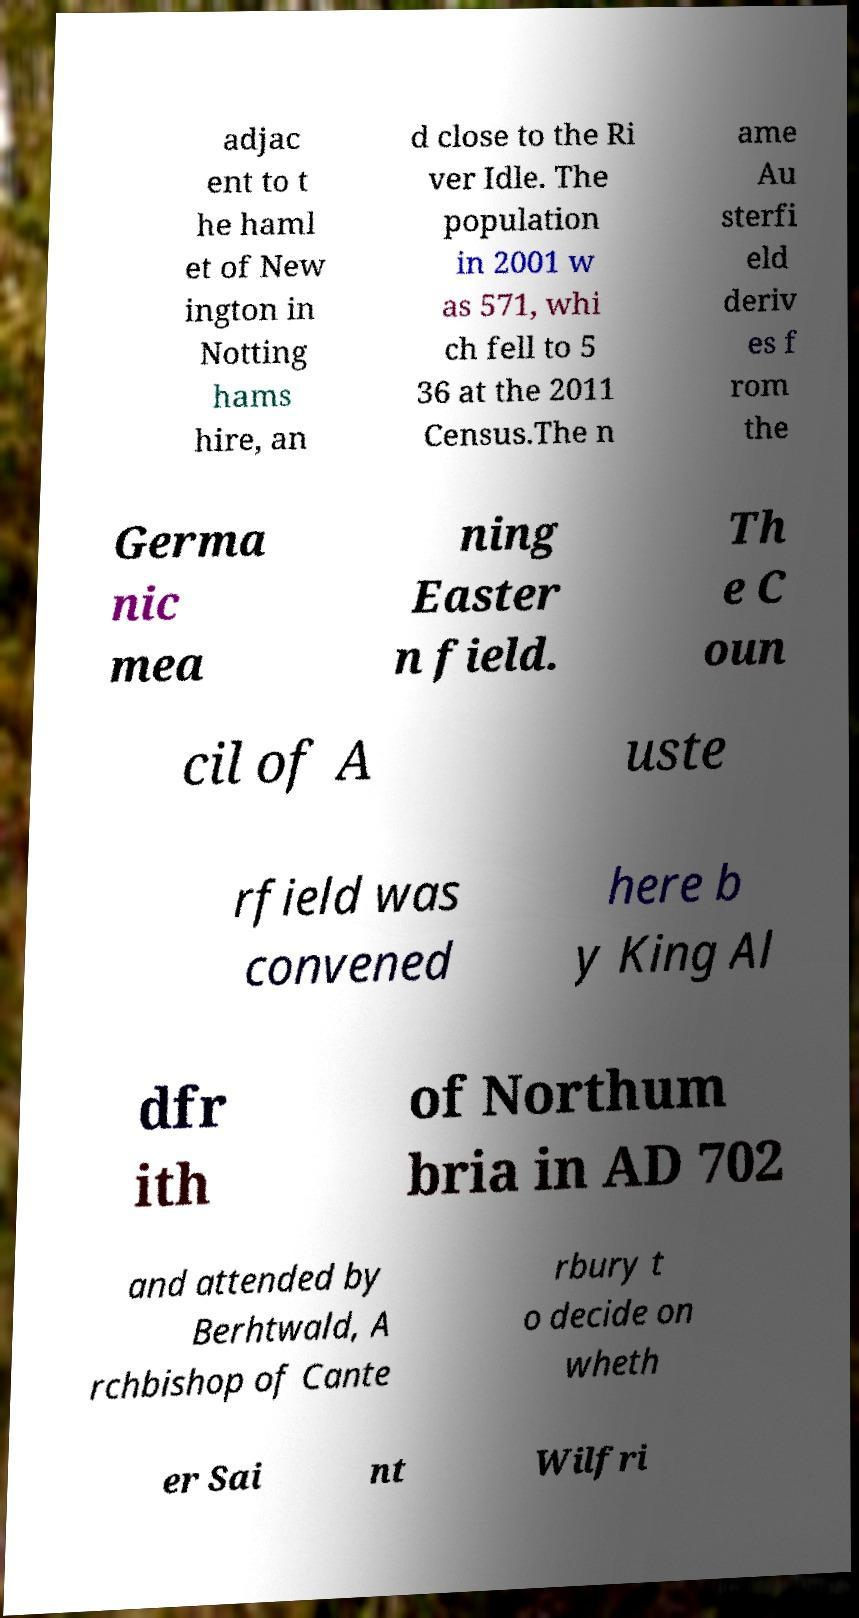Can you read and provide the text displayed in the image?This photo seems to have some interesting text. Can you extract and type it out for me? adjac ent to t he haml et of New ington in Notting hams hire, an d close to the Ri ver Idle. The population in 2001 w as 571, whi ch fell to 5 36 at the 2011 Census.The n ame Au sterfi eld deriv es f rom the Germa nic mea ning Easter n field. Th e C oun cil of A uste rfield was convened here b y King Al dfr ith of Northum bria in AD 702 and attended by Berhtwald, A rchbishop of Cante rbury t o decide on wheth er Sai nt Wilfri 